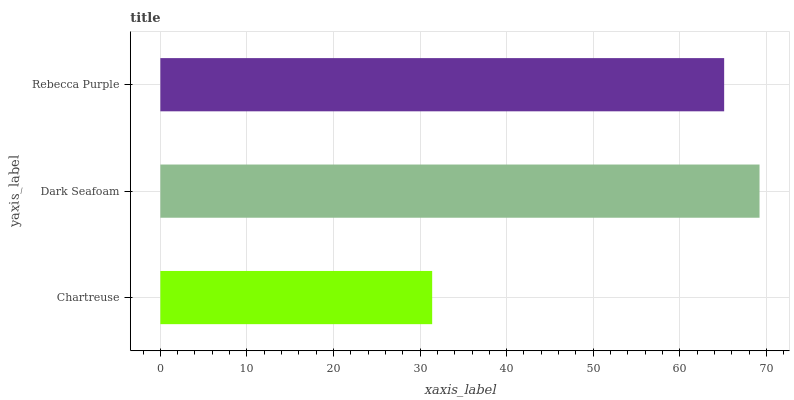Is Chartreuse the minimum?
Answer yes or no. Yes. Is Dark Seafoam the maximum?
Answer yes or no. Yes. Is Rebecca Purple the minimum?
Answer yes or no. No. Is Rebecca Purple the maximum?
Answer yes or no. No. Is Dark Seafoam greater than Rebecca Purple?
Answer yes or no. Yes. Is Rebecca Purple less than Dark Seafoam?
Answer yes or no. Yes. Is Rebecca Purple greater than Dark Seafoam?
Answer yes or no. No. Is Dark Seafoam less than Rebecca Purple?
Answer yes or no. No. Is Rebecca Purple the high median?
Answer yes or no. Yes. Is Rebecca Purple the low median?
Answer yes or no. Yes. Is Dark Seafoam the high median?
Answer yes or no. No. Is Dark Seafoam the low median?
Answer yes or no. No. 